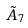Convert formula to latex. <formula><loc_0><loc_0><loc_500><loc_500>\tilde { A } _ { 7 }</formula> 